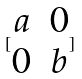<formula> <loc_0><loc_0><loc_500><loc_500>[ \begin{matrix} a & 0 \\ 0 & b \end{matrix} ]</formula> 